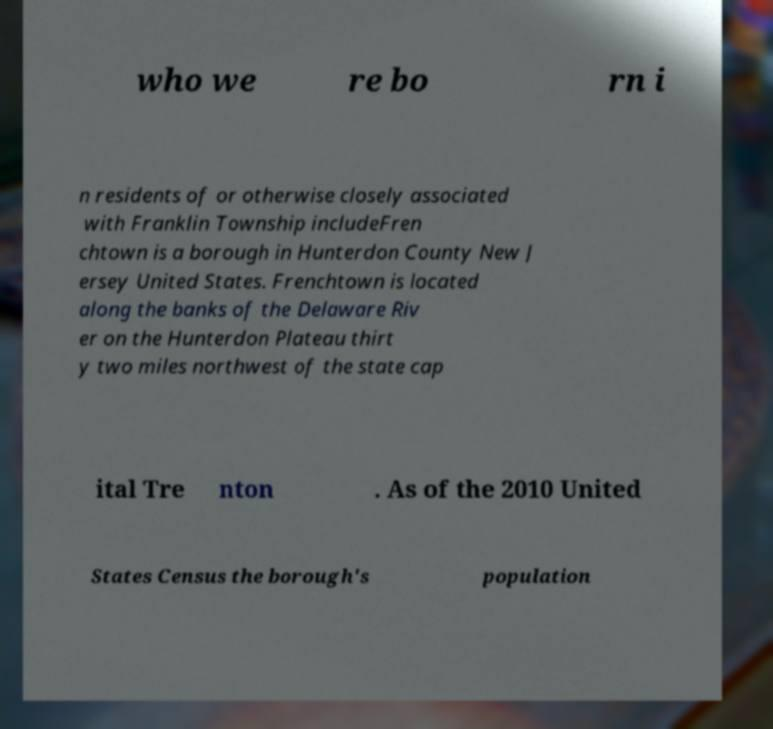There's text embedded in this image that I need extracted. Can you transcribe it verbatim? who we re bo rn i n residents of or otherwise closely associated with Franklin Township includeFren chtown is a borough in Hunterdon County New J ersey United States. Frenchtown is located along the banks of the Delaware Riv er on the Hunterdon Plateau thirt y two miles northwest of the state cap ital Tre nton . As of the 2010 United States Census the borough's population 